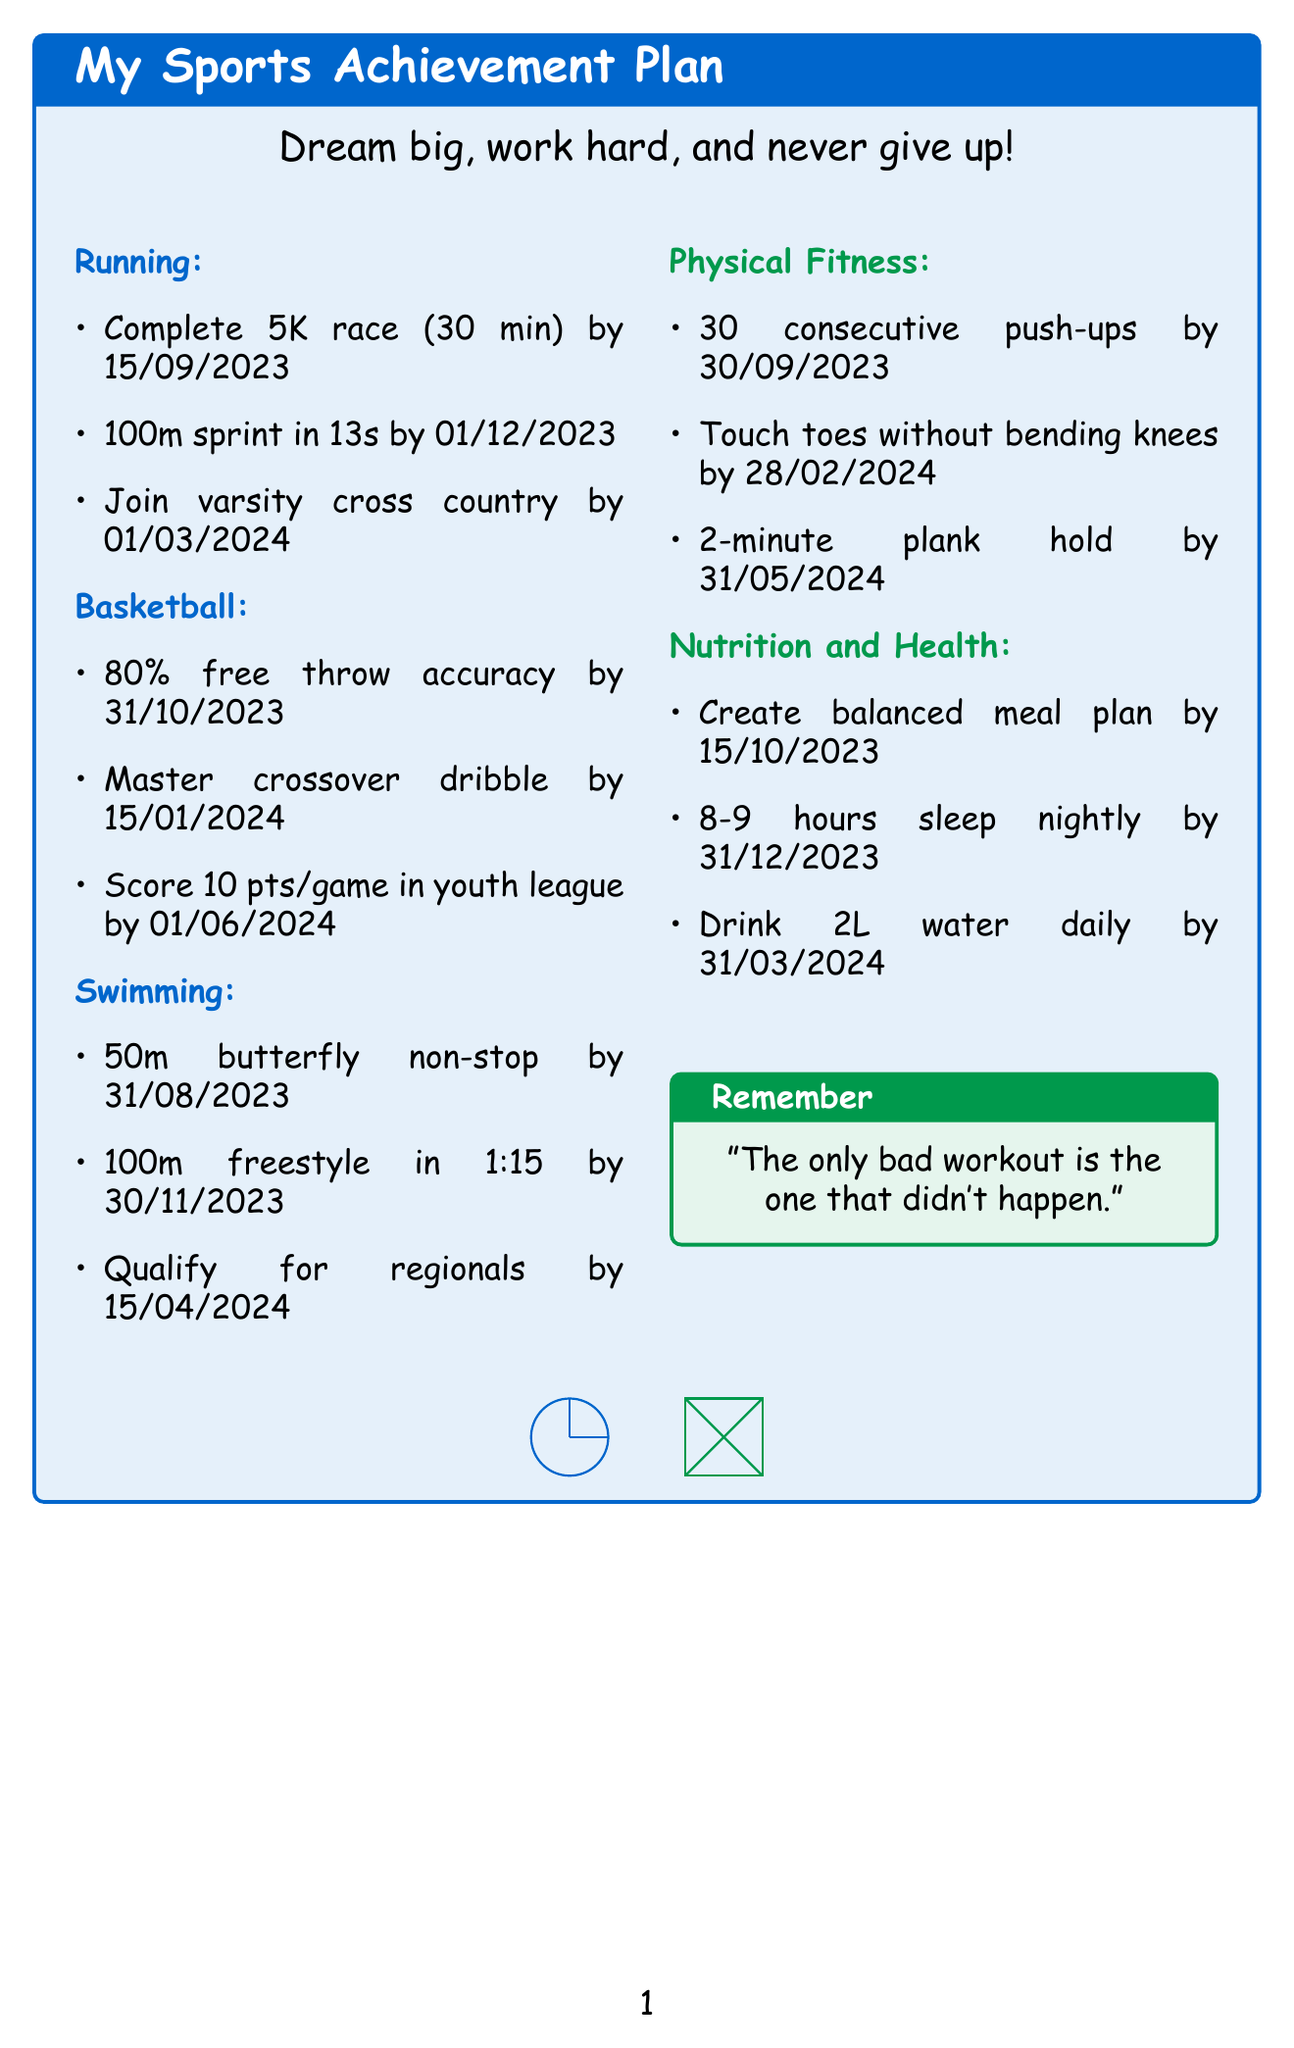what is the first goal in the Running category? The first goal listed in the Running category is to complete the first 5K race.
Answer: Complete first 5K race when is the target date for improving free throw accuracy? The target date for improving free throw accuracy in the Basketball category is specified in the document.
Answer: 2023-10-31 how many push-ups is the target goal for physical fitness? The target goal for physical fitness related to push-ups is outlined in the document.
Answer: 30 consecutive push-ups what specific goal is set for the butterfly stroke? The document states the specific goal related to learning the butterfly stroke in the Swimming category.
Answer: Swim 50m without stopping which category has a milestone for joining a youth basketball league? The document specifies that the goal to join a youth basketball league falls under a particular category.
Answer: Basketball what is the specific goal for the 100m freestyle time? The specific goal for improving the 100m freestyle time is mentioned in the document.
Answer: Reach under 1 minute 15 seconds what is the last goal listed in the Nutrition and Health category? The document outlines the last goal within the specified Nutrition and Health category.
Answer: Drink at least 2 liters of water daily how many hours sleep nightly is the target goal for establishing a sleep schedule? The target goal for the sleep schedule is specified in the Nutrition and Health section of the document.
Answer: Sleep 8-9 hours nightly 